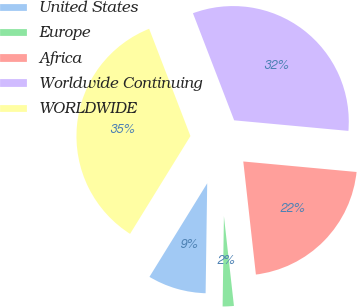<chart> <loc_0><loc_0><loc_500><loc_500><pie_chart><fcel>United States<fcel>Europe<fcel>Africa<fcel>Worldwide Continuing<fcel>WORLDWIDE<nl><fcel>8.57%<fcel>2.0%<fcel>21.76%<fcel>32.32%<fcel>35.35%<nl></chart> 